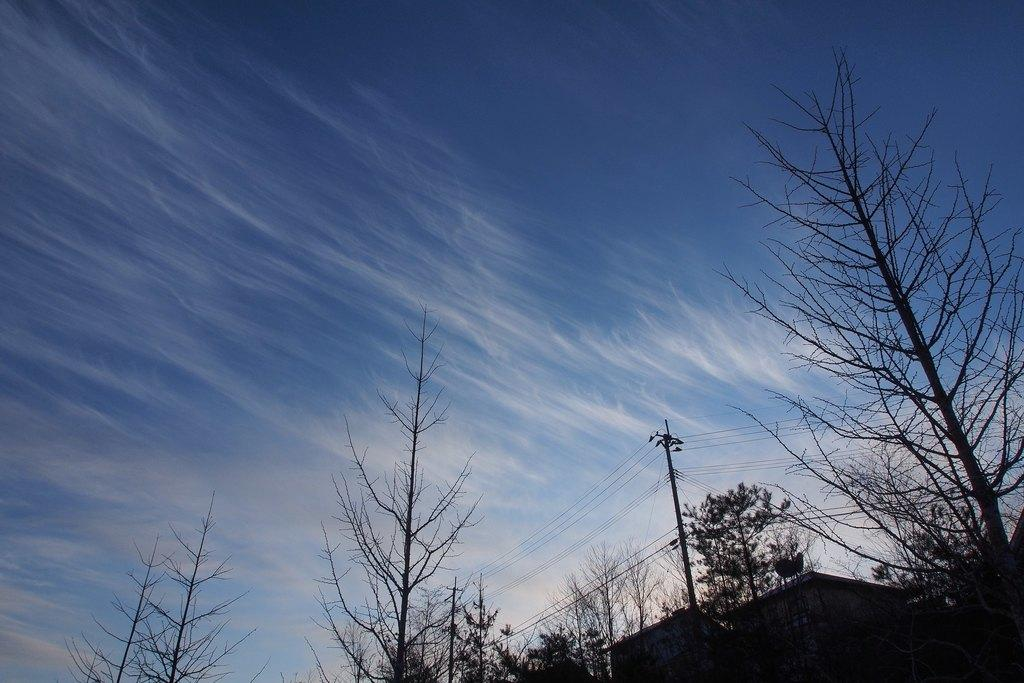What type of vegetation is at the bottom of the image? There are trees at the bottom of the image. What structure can be seen in the image? There is a pole in the image. What else is present in the image besides the pole? There are wires in the image. What can be seen in the background of the image? The sky is visible in the background of the image. What type of ink is used to draw the trees in the image? There is no indication that the image is a drawing, and even if it were, there is no information about the type of ink used. Can you see a knife in the image? No, there is no knife present in the image. 